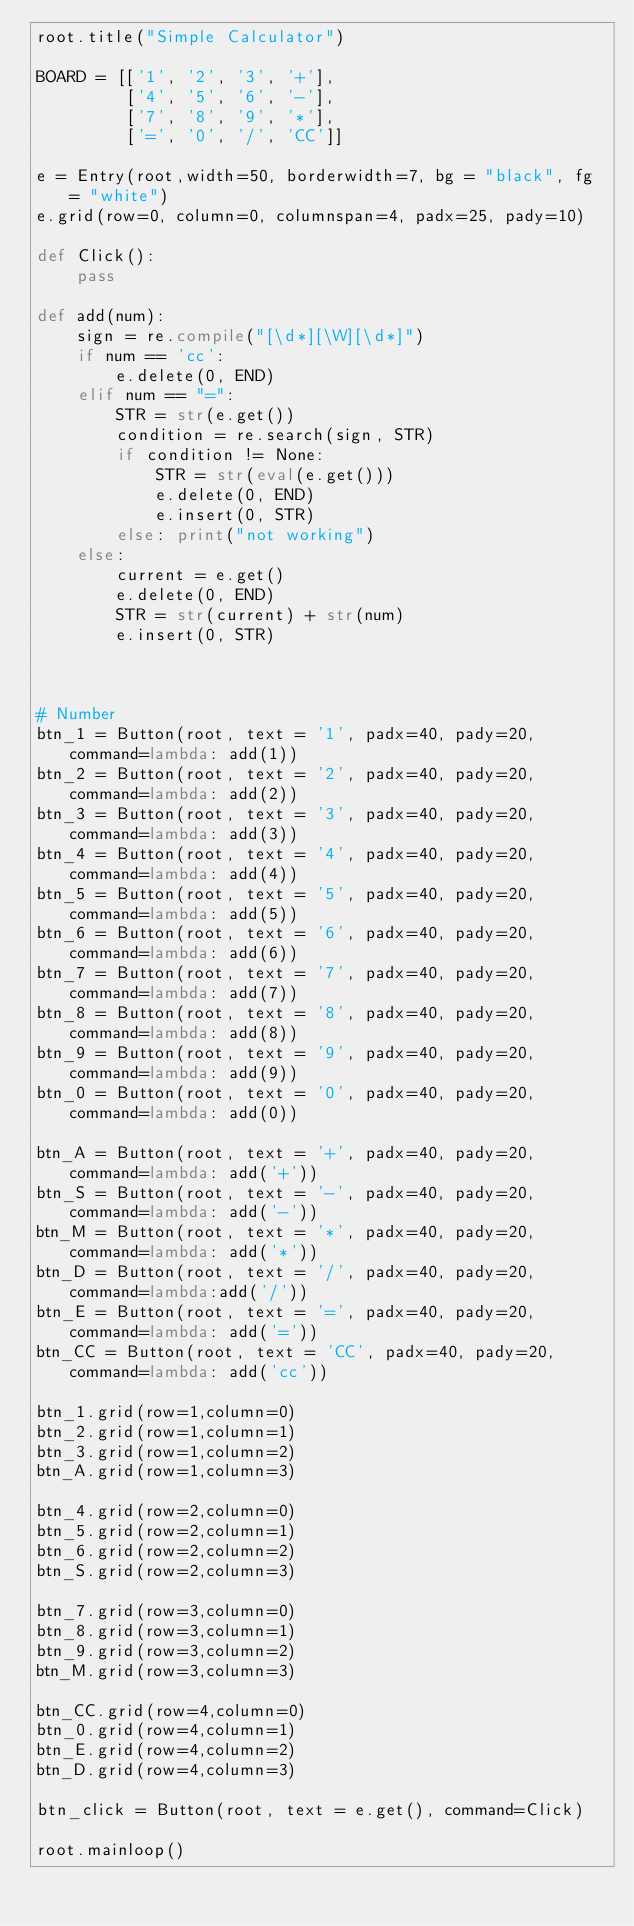Convert code to text. <code><loc_0><loc_0><loc_500><loc_500><_Python_>root.title("Simple Calculator")

BOARD = [['1', '2', '3', '+'],
         ['4', '5', '6', '-'],
         ['7', '8', '9', '*'],
         ['=', '0', '/', 'CC']]

e = Entry(root,width=50, borderwidth=7, bg = "black", fg = "white")
e.grid(row=0, column=0, columnspan=4, padx=25, pady=10)

def Click():
    pass

def add(num):
    sign = re.compile("[\d*][\W][\d*]")
    if num == 'cc':
        e.delete(0, END)
    elif num == "=":
        STR = str(e.get())
        condition = re.search(sign, STR)
        if condition != None: 
            STR = str(eval(e.get()))
            e.delete(0, END)
            e.insert(0, STR)
        else: print("not working")
    else:
        current = e.get()
        e.delete(0, END)
        STR = str(current) + str(num)
        e.insert(0, STR)

    

# Number
btn_1 = Button(root, text = '1', padx=40, pady=20, command=lambda: add(1))
btn_2 = Button(root, text = '2', padx=40, pady=20, command=lambda: add(2))
btn_3 = Button(root, text = '3', padx=40, pady=20, command=lambda: add(3))
btn_4 = Button(root, text = '4', padx=40, pady=20, command=lambda: add(4))
btn_5 = Button(root, text = '5', padx=40, pady=20, command=lambda: add(5))
btn_6 = Button(root, text = '6', padx=40, pady=20, command=lambda: add(6))
btn_7 = Button(root, text = '7', padx=40, pady=20, command=lambda: add(7))
btn_8 = Button(root, text = '8', padx=40, pady=20, command=lambda: add(8))
btn_9 = Button(root, text = '9', padx=40, pady=20, command=lambda: add(9))
btn_0 = Button(root, text = '0', padx=40, pady=20, command=lambda: add(0))

btn_A = Button(root, text = '+', padx=40, pady=20, command=lambda: add('+'))
btn_S = Button(root, text = '-', padx=40, pady=20, command=lambda: add('-'))
btn_M = Button(root, text = '*', padx=40, pady=20, command=lambda: add('*'))
btn_D = Button(root, text = '/', padx=40, pady=20, command=lambda:add('/'))
btn_E = Button(root, text = '=', padx=40, pady=20, command=lambda: add('='))
btn_CC = Button(root, text = 'CC', padx=40, pady=20, command=lambda: add('cc'))

btn_1.grid(row=1,column=0)
btn_2.grid(row=1,column=1)
btn_3.grid(row=1,column=2)
btn_A.grid(row=1,column=3)

btn_4.grid(row=2,column=0)
btn_5.grid(row=2,column=1)
btn_6.grid(row=2,column=2)
btn_S.grid(row=2,column=3)

btn_7.grid(row=3,column=0)
btn_8.grid(row=3,column=1)
btn_9.grid(row=3,column=2)
btn_M.grid(row=3,column=3)

btn_CC.grid(row=4,column=0)
btn_0.grid(row=4,column=1)
btn_E.grid(row=4,column=2)
btn_D.grid(row=4,column=3)

btn_click = Button(root, text = e.get(), command=Click)

root.mainloop()
</code> 